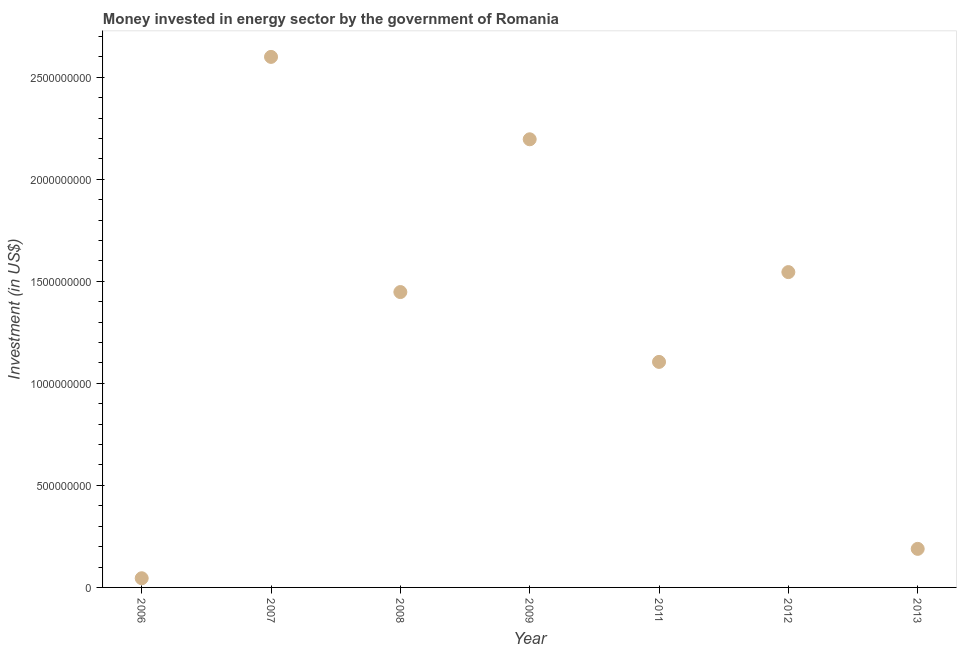What is the investment in energy in 2011?
Your response must be concise. 1.11e+09. Across all years, what is the maximum investment in energy?
Your answer should be very brief. 2.60e+09. Across all years, what is the minimum investment in energy?
Make the answer very short. 4.50e+07. What is the sum of the investment in energy?
Provide a succinct answer. 9.13e+09. What is the difference between the investment in energy in 2012 and 2013?
Offer a very short reply. 1.36e+09. What is the average investment in energy per year?
Provide a succinct answer. 1.30e+09. What is the median investment in energy?
Offer a terse response. 1.45e+09. Do a majority of the years between 2009 and 2013 (inclusive) have investment in energy greater than 400000000 US$?
Provide a short and direct response. Yes. What is the ratio of the investment in energy in 2009 to that in 2011?
Make the answer very short. 1.99. Is the investment in energy in 2006 less than that in 2007?
Your answer should be compact. Yes. Is the difference between the investment in energy in 2008 and 2011 greater than the difference between any two years?
Ensure brevity in your answer.  No. What is the difference between the highest and the second highest investment in energy?
Offer a very short reply. 4.04e+08. What is the difference between the highest and the lowest investment in energy?
Ensure brevity in your answer.  2.56e+09. Does the investment in energy monotonically increase over the years?
Keep it short and to the point. No. How many dotlines are there?
Provide a succinct answer. 1. Does the graph contain any zero values?
Your response must be concise. No. Does the graph contain grids?
Keep it short and to the point. No. What is the title of the graph?
Provide a succinct answer. Money invested in energy sector by the government of Romania. What is the label or title of the X-axis?
Offer a very short reply. Year. What is the label or title of the Y-axis?
Offer a very short reply. Investment (in US$). What is the Investment (in US$) in 2006?
Offer a terse response. 4.50e+07. What is the Investment (in US$) in 2007?
Your answer should be compact. 2.60e+09. What is the Investment (in US$) in 2008?
Give a very brief answer. 1.45e+09. What is the Investment (in US$) in 2009?
Make the answer very short. 2.20e+09. What is the Investment (in US$) in 2011?
Your answer should be very brief. 1.11e+09. What is the Investment (in US$) in 2012?
Your response must be concise. 1.55e+09. What is the Investment (in US$) in 2013?
Your answer should be compact. 1.89e+08. What is the difference between the Investment (in US$) in 2006 and 2007?
Offer a very short reply. -2.56e+09. What is the difference between the Investment (in US$) in 2006 and 2008?
Provide a succinct answer. -1.40e+09. What is the difference between the Investment (in US$) in 2006 and 2009?
Offer a very short reply. -2.15e+09. What is the difference between the Investment (in US$) in 2006 and 2011?
Ensure brevity in your answer.  -1.06e+09. What is the difference between the Investment (in US$) in 2006 and 2012?
Give a very brief answer. -1.50e+09. What is the difference between the Investment (in US$) in 2006 and 2013?
Provide a succinct answer. -1.44e+08. What is the difference between the Investment (in US$) in 2007 and 2008?
Ensure brevity in your answer.  1.15e+09. What is the difference between the Investment (in US$) in 2007 and 2009?
Give a very brief answer. 4.04e+08. What is the difference between the Investment (in US$) in 2007 and 2011?
Your answer should be compact. 1.49e+09. What is the difference between the Investment (in US$) in 2007 and 2012?
Provide a succinct answer. 1.05e+09. What is the difference between the Investment (in US$) in 2007 and 2013?
Give a very brief answer. 2.41e+09. What is the difference between the Investment (in US$) in 2008 and 2009?
Your answer should be compact. -7.49e+08. What is the difference between the Investment (in US$) in 2008 and 2011?
Keep it short and to the point. 3.42e+08. What is the difference between the Investment (in US$) in 2008 and 2012?
Make the answer very short. -9.78e+07. What is the difference between the Investment (in US$) in 2008 and 2013?
Ensure brevity in your answer.  1.26e+09. What is the difference between the Investment (in US$) in 2009 and 2011?
Your response must be concise. 1.09e+09. What is the difference between the Investment (in US$) in 2009 and 2012?
Offer a terse response. 6.51e+08. What is the difference between the Investment (in US$) in 2009 and 2013?
Make the answer very short. 2.01e+09. What is the difference between the Investment (in US$) in 2011 and 2012?
Your response must be concise. -4.40e+08. What is the difference between the Investment (in US$) in 2011 and 2013?
Your answer should be compact. 9.16e+08. What is the difference between the Investment (in US$) in 2012 and 2013?
Keep it short and to the point. 1.36e+09. What is the ratio of the Investment (in US$) in 2006 to that in 2007?
Your answer should be very brief. 0.02. What is the ratio of the Investment (in US$) in 2006 to that in 2008?
Keep it short and to the point. 0.03. What is the ratio of the Investment (in US$) in 2006 to that in 2009?
Make the answer very short. 0.02. What is the ratio of the Investment (in US$) in 2006 to that in 2011?
Your answer should be very brief. 0.04. What is the ratio of the Investment (in US$) in 2006 to that in 2012?
Give a very brief answer. 0.03. What is the ratio of the Investment (in US$) in 2006 to that in 2013?
Your answer should be compact. 0.24. What is the ratio of the Investment (in US$) in 2007 to that in 2008?
Make the answer very short. 1.8. What is the ratio of the Investment (in US$) in 2007 to that in 2009?
Provide a succinct answer. 1.18. What is the ratio of the Investment (in US$) in 2007 to that in 2011?
Provide a succinct answer. 2.35. What is the ratio of the Investment (in US$) in 2007 to that in 2012?
Give a very brief answer. 1.68. What is the ratio of the Investment (in US$) in 2007 to that in 2013?
Your answer should be very brief. 13.76. What is the ratio of the Investment (in US$) in 2008 to that in 2009?
Your answer should be very brief. 0.66. What is the ratio of the Investment (in US$) in 2008 to that in 2011?
Give a very brief answer. 1.31. What is the ratio of the Investment (in US$) in 2008 to that in 2012?
Give a very brief answer. 0.94. What is the ratio of the Investment (in US$) in 2008 to that in 2013?
Your response must be concise. 7.66. What is the ratio of the Investment (in US$) in 2009 to that in 2011?
Offer a very short reply. 1.99. What is the ratio of the Investment (in US$) in 2009 to that in 2012?
Provide a short and direct response. 1.42. What is the ratio of the Investment (in US$) in 2009 to that in 2013?
Offer a terse response. 11.62. What is the ratio of the Investment (in US$) in 2011 to that in 2012?
Your answer should be very brief. 0.71. What is the ratio of the Investment (in US$) in 2011 to that in 2013?
Keep it short and to the point. 5.85. What is the ratio of the Investment (in US$) in 2012 to that in 2013?
Ensure brevity in your answer.  8.18. 